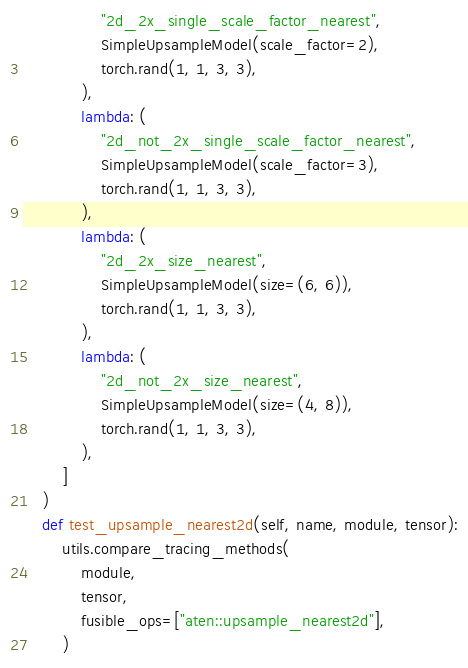<code> <loc_0><loc_0><loc_500><loc_500><_Python_>                "2d_2x_single_scale_factor_nearest",
                SimpleUpsampleModel(scale_factor=2),
                torch.rand(1, 1, 3, 3),
            ),
            lambda: (
                "2d_not_2x_single_scale_factor_nearest",
                SimpleUpsampleModel(scale_factor=3),
                torch.rand(1, 1, 3, 3),
            ),
            lambda: (
                "2d_2x_size_nearest",
                SimpleUpsampleModel(size=(6, 6)),
                torch.rand(1, 1, 3, 3),
            ),
            lambda: (
                "2d_not_2x_size_nearest",
                SimpleUpsampleModel(size=(4, 8)),
                torch.rand(1, 1, 3, 3),
            ),
        ]
    )
    def test_upsample_nearest2d(self, name, module, tensor):
        utils.compare_tracing_methods(
            module,
            tensor,
            fusible_ops=["aten::upsample_nearest2d"],
        )
</code> 